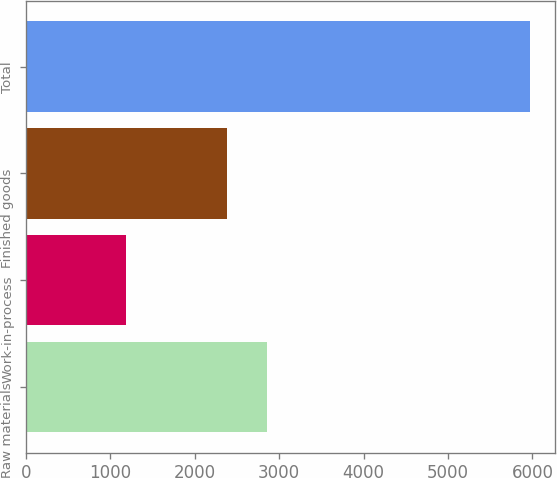Convert chart. <chart><loc_0><loc_0><loc_500><loc_500><bar_chart><fcel>Raw materials<fcel>Work-in-process<fcel>Finished goods<fcel>Total<nl><fcel>2857.3<fcel>1183<fcel>2379<fcel>5966<nl></chart> 